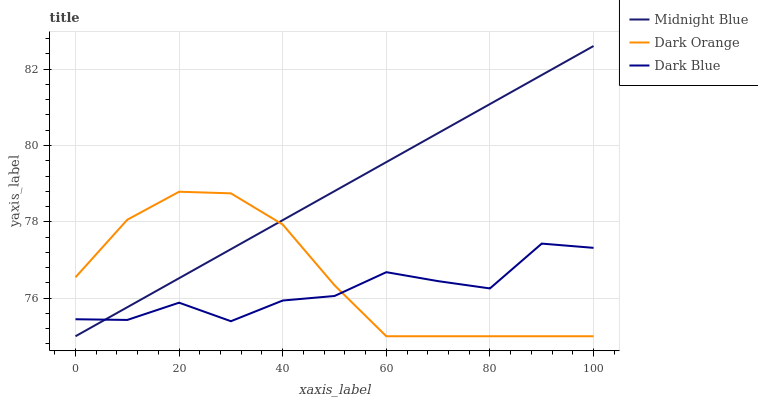Does Dark Blue have the minimum area under the curve?
Answer yes or no. Yes. Does Midnight Blue have the maximum area under the curve?
Answer yes or no. Yes. Does Midnight Blue have the minimum area under the curve?
Answer yes or no. No. Does Dark Blue have the maximum area under the curve?
Answer yes or no. No. Is Midnight Blue the smoothest?
Answer yes or no. Yes. Is Dark Blue the roughest?
Answer yes or no. Yes. Is Dark Blue the smoothest?
Answer yes or no. No. Is Midnight Blue the roughest?
Answer yes or no. No. Does Dark Orange have the lowest value?
Answer yes or no. Yes. Does Dark Blue have the lowest value?
Answer yes or no. No. Does Midnight Blue have the highest value?
Answer yes or no. Yes. Does Dark Blue have the highest value?
Answer yes or no. No. Does Midnight Blue intersect Dark Orange?
Answer yes or no. Yes. Is Midnight Blue less than Dark Orange?
Answer yes or no. No. Is Midnight Blue greater than Dark Orange?
Answer yes or no. No. 